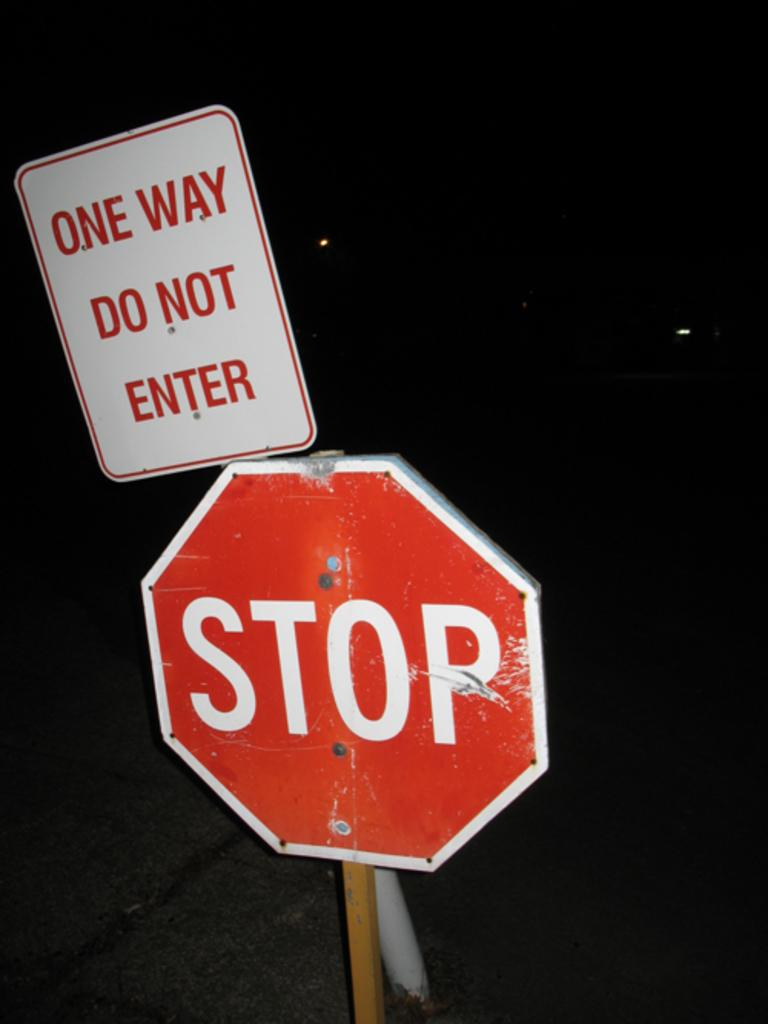<image>
Offer a succinct explanation of the picture presented. A sign behind a stop sign indicates a one way direction. 